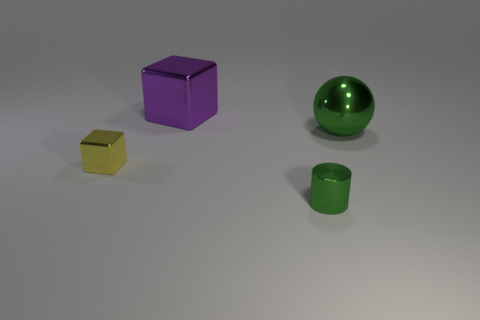Do the cylinder and the ball have the same color?
Offer a very short reply. Yes. There is a shiny object that is the same color as the cylinder; what shape is it?
Make the answer very short. Sphere. There is a metallic thing to the left of the metallic object behind the big green sphere; is there a tiny object in front of it?
Your response must be concise. Yes. What color is the other thing that is the same shape as the small yellow metal object?
Your answer should be compact. Purple. Is there any other thing that is the same shape as the small green metal thing?
Give a very brief answer. No. Is the number of big metallic objects that are behind the large purple shiny block the same as the number of tiny cyan cubes?
Provide a short and direct response. Yes. Are there any large blocks to the left of the purple shiny block?
Provide a short and direct response. No. What size is the metal cube to the right of the shiny object left of the shiny cube behind the tiny yellow thing?
Ensure brevity in your answer.  Large. There is a tiny metallic object to the left of the big metallic block; is it the same shape as the large shiny thing to the left of the small green thing?
Your answer should be very brief. Yes. There is another object that is the same shape as the big purple thing; what is its size?
Your response must be concise. Small. 